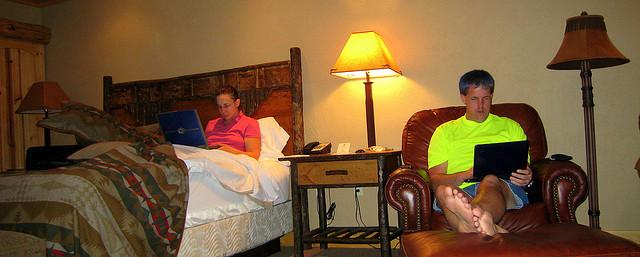Why are they so far apart? Please explain your reasoning. quiet time. Both people separately seated in this image show deep concentration and attention towards their devices and likely need each other to be quiet. 